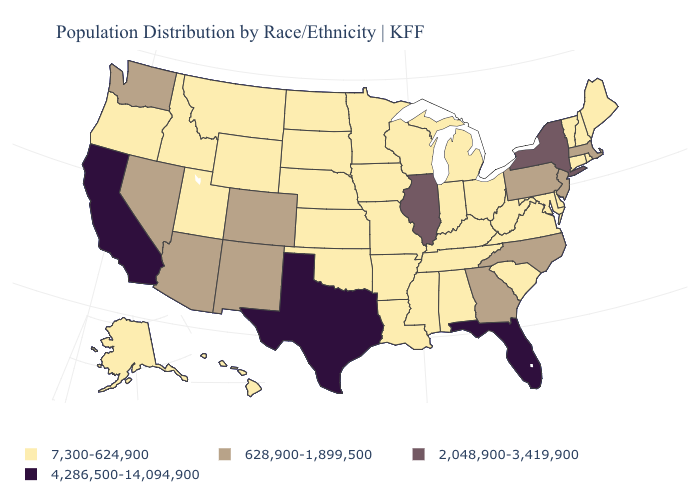Does Connecticut have the lowest value in the USA?
Short answer required. Yes. Does Oregon have the same value as Massachusetts?
Short answer required. No. What is the highest value in the USA?
Answer briefly. 4,286,500-14,094,900. Is the legend a continuous bar?
Be succinct. No. Among the states that border Connecticut , does Rhode Island have the highest value?
Answer briefly. No. Among the states that border Ohio , does Pennsylvania have the lowest value?
Keep it brief. No. Does Rhode Island have the lowest value in the Northeast?
Write a very short answer. Yes. Does the map have missing data?
Concise answer only. No. What is the value of Florida?
Be succinct. 4,286,500-14,094,900. Does New York have the highest value in the Northeast?
Give a very brief answer. Yes. How many symbols are there in the legend?
Short answer required. 4. Name the states that have a value in the range 7,300-624,900?
Quick response, please. Alabama, Alaska, Arkansas, Connecticut, Delaware, Hawaii, Idaho, Indiana, Iowa, Kansas, Kentucky, Louisiana, Maine, Maryland, Michigan, Minnesota, Mississippi, Missouri, Montana, Nebraska, New Hampshire, North Dakota, Ohio, Oklahoma, Oregon, Rhode Island, South Carolina, South Dakota, Tennessee, Utah, Vermont, Virginia, West Virginia, Wisconsin, Wyoming. Which states have the lowest value in the South?
Short answer required. Alabama, Arkansas, Delaware, Kentucky, Louisiana, Maryland, Mississippi, Oklahoma, South Carolina, Tennessee, Virginia, West Virginia. Is the legend a continuous bar?
Short answer required. No. 